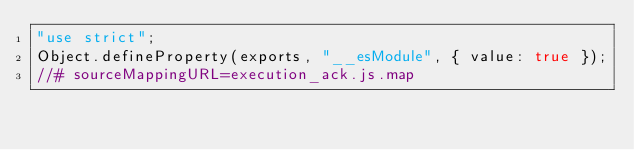<code> <loc_0><loc_0><loc_500><loc_500><_JavaScript_>"use strict";
Object.defineProperty(exports, "__esModule", { value: true });
//# sourceMappingURL=execution_ack.js.map</code> 